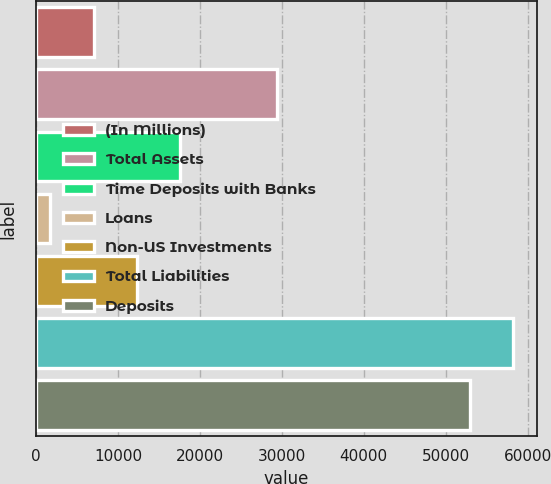<chart> <loc_0><loc_0><loc_500><loc_500><bar_chart><fcel>(In Millions)<fcel>Total Assets<fcel>Time Deposits with Banks<fcel>Loans<fcel>Non-US Investments<fcel>Total Liabilities<fcel>Deposits<nl><fcel>7035.56<fcel>29411.2<fcel>17587.9<fcel>1759.4<fcel>12311.7<fcel>58257.4<fcel>52981.2<nl></chart> 